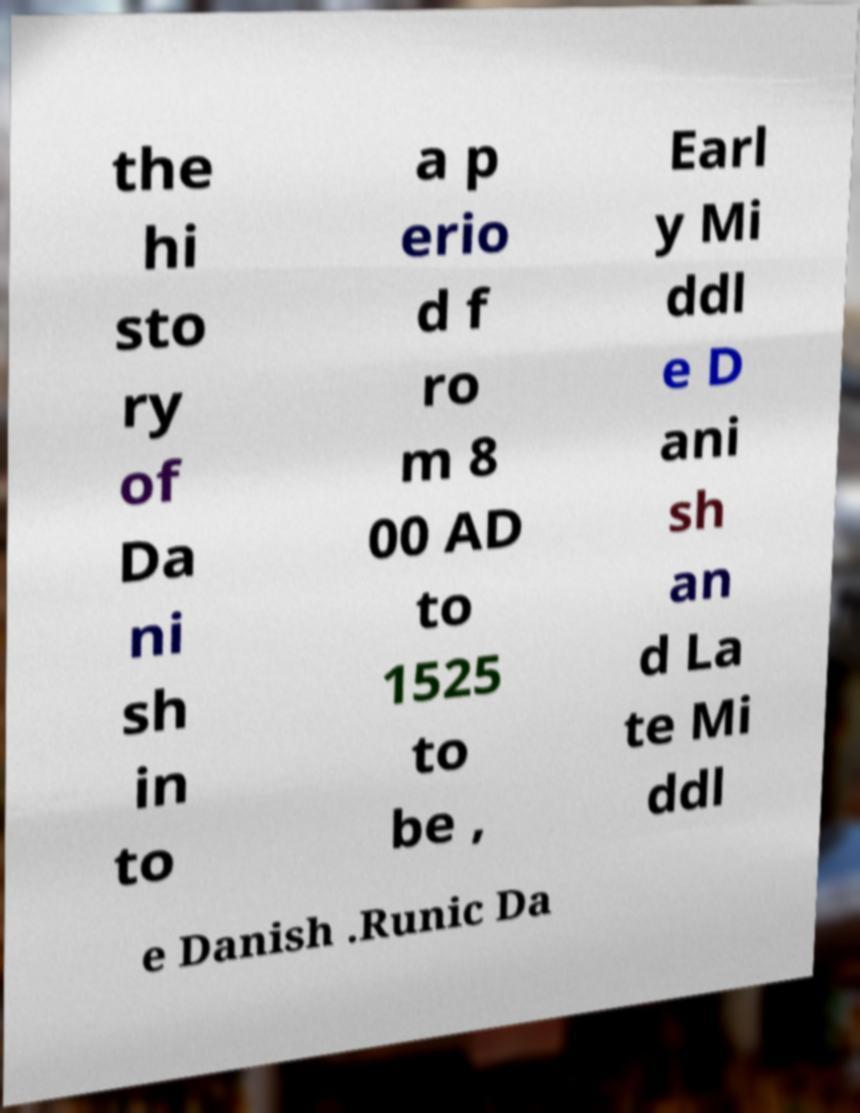For documentation purposes, I need the text within this image transcribed. Could you provide that? the hi sto ry of Da ni sh in to a p erio d f ro m 8 00 AD to 1525 to be , Earl y Mi ddl e D ani sh an d La te Mi ddl e Danish .Runic Da 